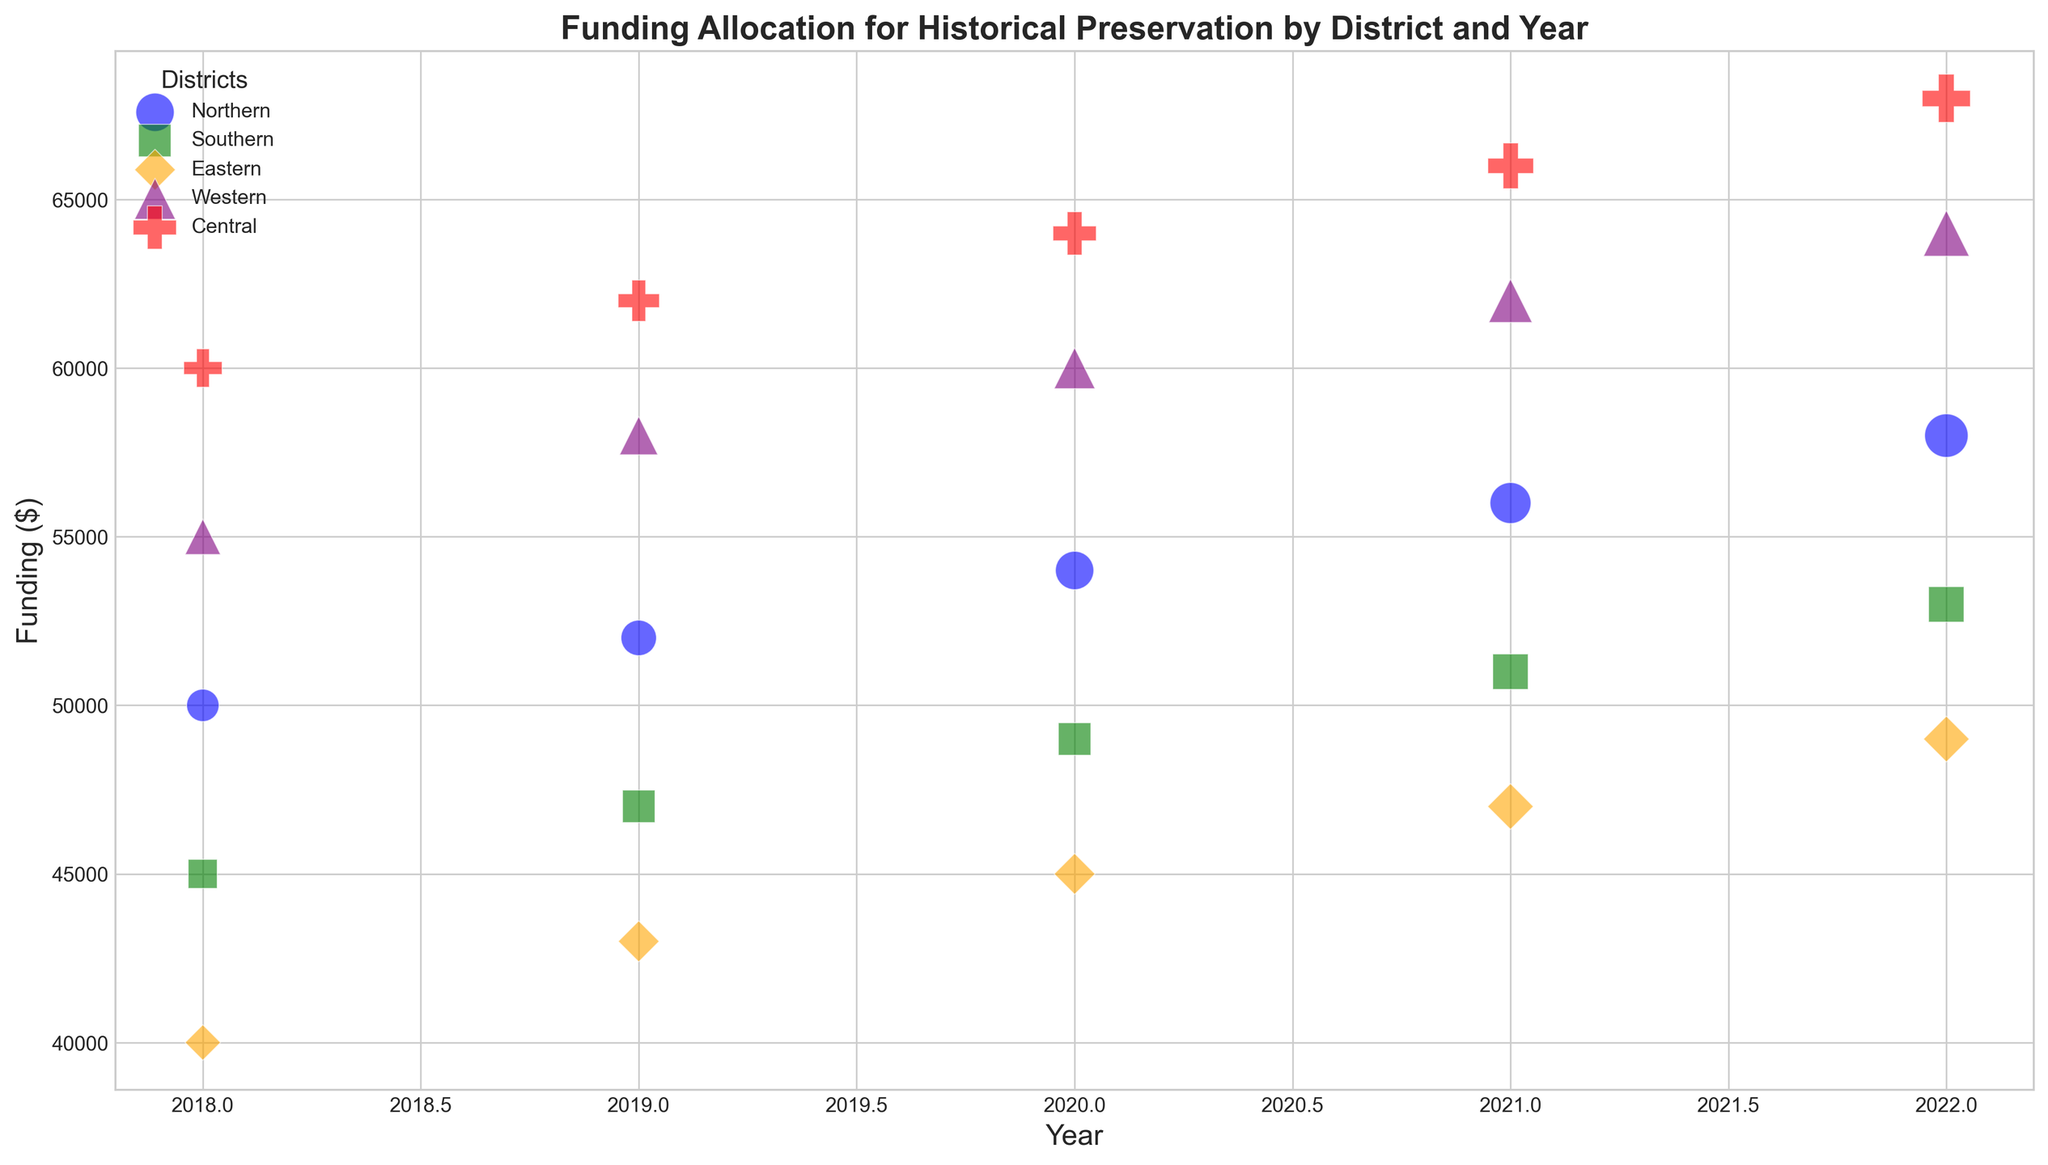What district received the highest funding in 2022? Look for the largest bubble on the far right side of the chart for the year 2022. The red bubble for the Central district is the highest.
Answer: Central Which year did Northern district receive its highest funding? Identify the largest blue bubble representing Northern district. It is located in 2022.
Answer: 2022 Compare the Eastern and Southern districts in terms of funding in 2020. Which one received more? Find the orange and green bubbles for the year 2020. The Southern district's (green) bubble is slightly higher than the Eastern district's (orange) bubble.
Answer: Southern How did the number of landmarks in the Central district change from 2018 to 2022? Compare the bubble sizes for the Central district (red) from 2018 to 2022. The bubble size increased, indicating more landmarks.
Answer: Increased Which district showed the greatest increase in funding from 2018 to 2022? Compare the vertical distances between the 2018 and 2022 bubbles for each district. The Central district (red) shows the largest vertical difference.
Answer: Central What is the average funding for the Western district from 2018 to 2022? Read the vertical positions of the purple bubbles for each year, add them, and divide by 5: (55000 + 58000 + 60000 + 62000 + 64000) / 5.
Answer: 59800 In 2021, which district had the most historical landmarks? Look at the largest bubble for the year 2021. The Central district (red) has the largest bubble.
Answer: Central Compare the funding for the Northern and Central districts in 2018. Which district received more? Compare the blue (Northern) and red (Central) bubbles for the year 2018. The Central district received more funding.
Answer: Central What trend do you observe in the funding for the Southern district from 2018 to 2022? Follow the green bubbles from 2018 to 2022. The funding shows a steady increase over the years.
Answer: Increasing By how much did the funding for the Western district increase from 2018 to 2022? Check the amount for the Western district (purple bubbles) in 2018 and 2022 and find the difference: 64000 - 55000.
Answer: 9000 